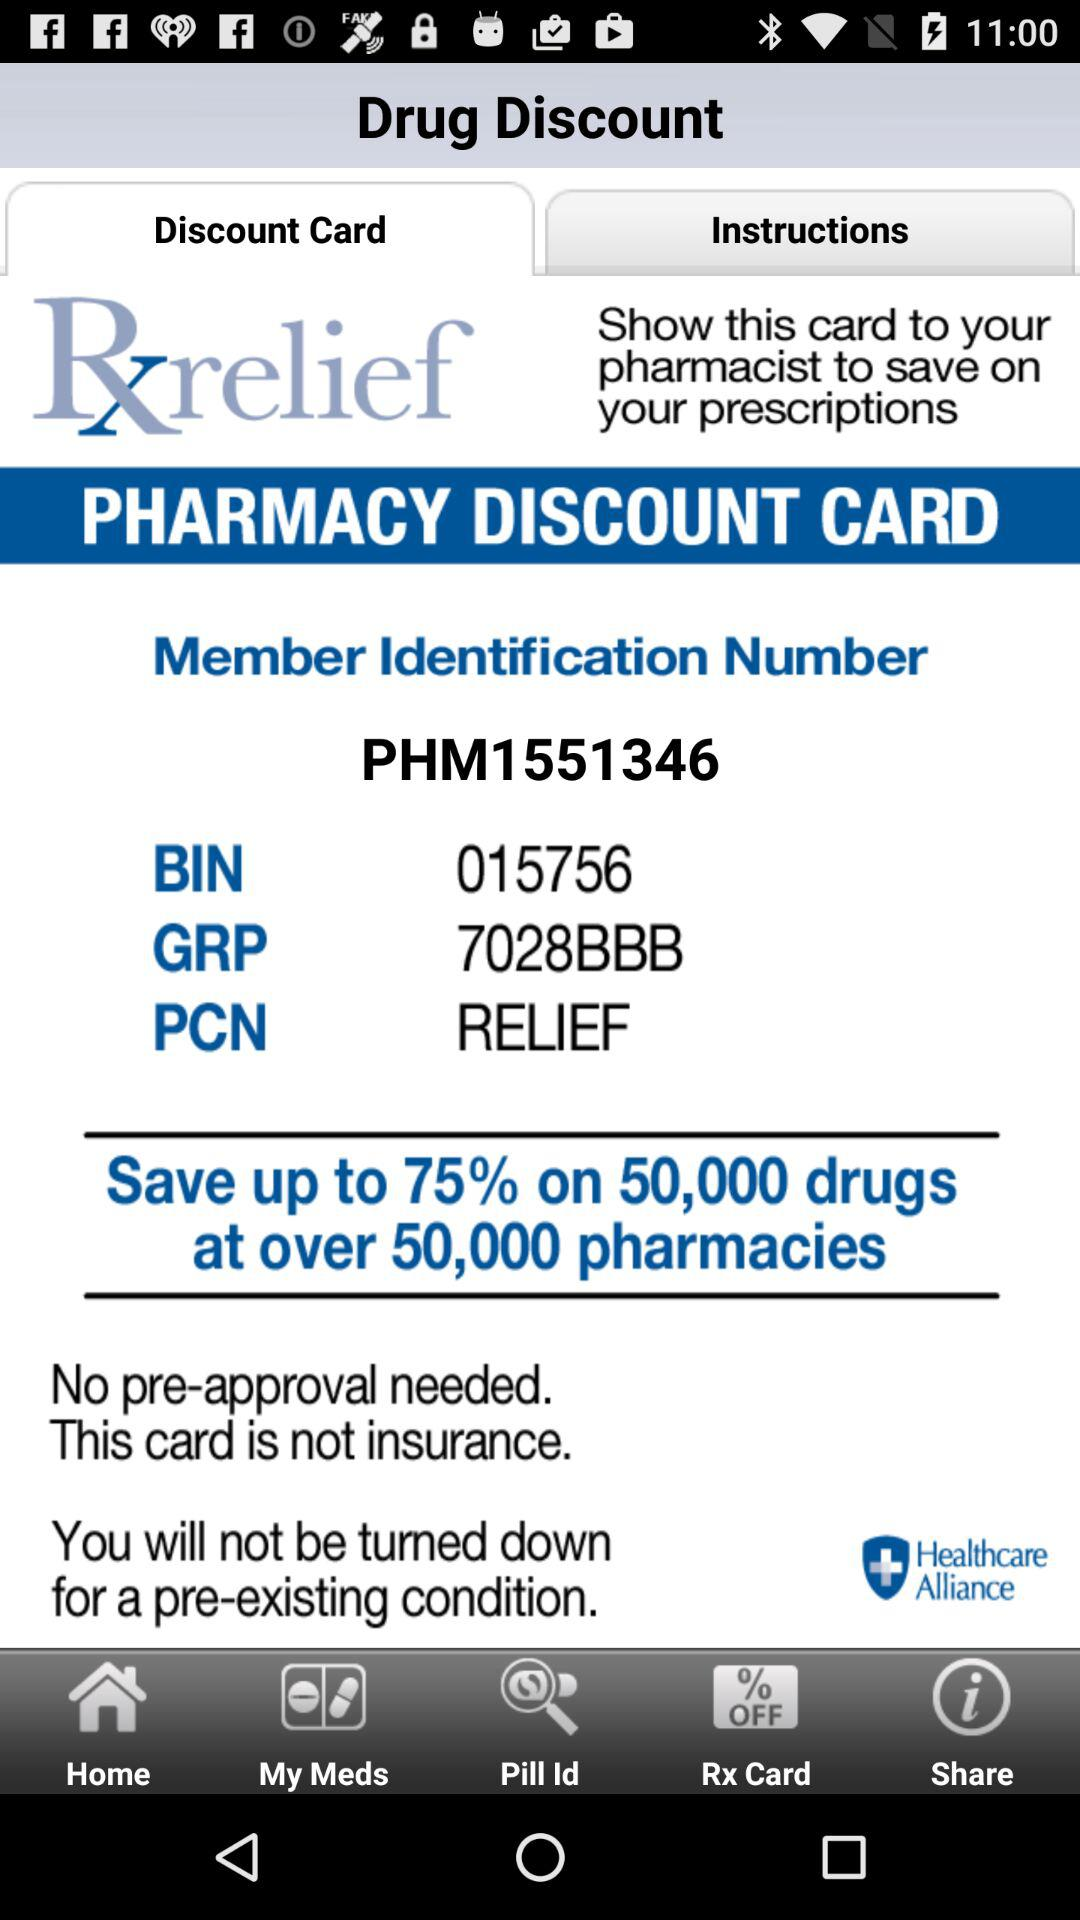What is the "Member Identification Number"? The "Member Identification Number" is "PHM1551346". 